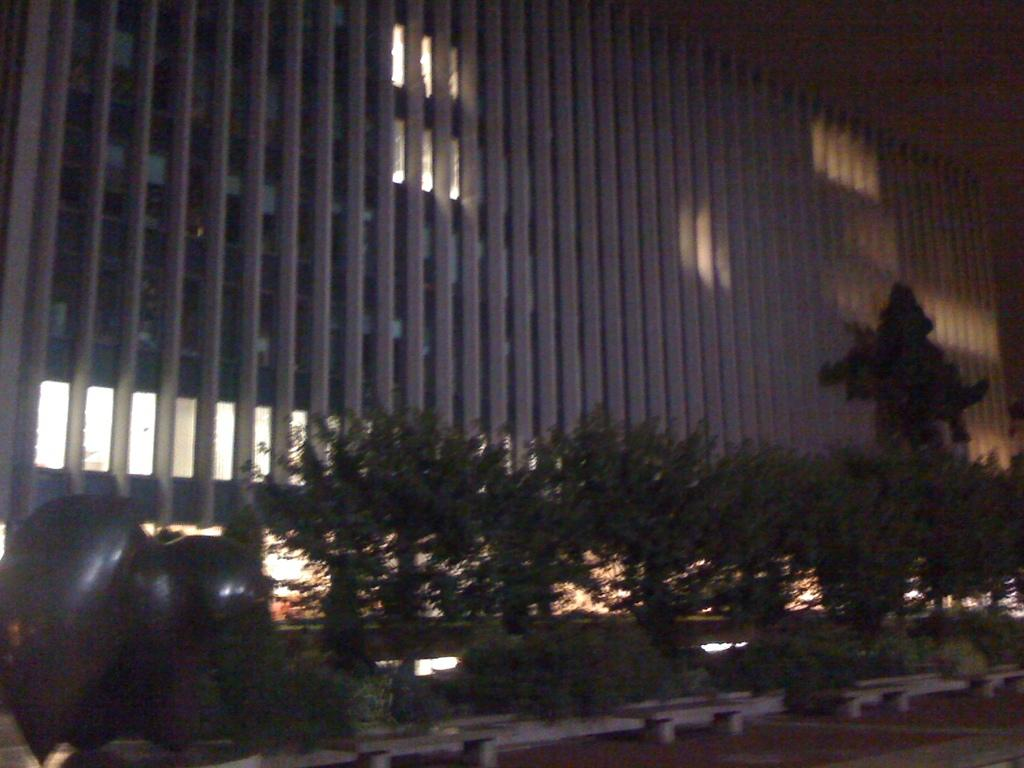What type of natural elements can be seen in the image? There are trees in the image. What type of man-made structure is visible in the background of the image? There is a building in the background of the image. Where is the sofa located in the image? There is no sofa present in the image. What type of meal is being served in the image? There is no meal or reference to breakfast in the image. 